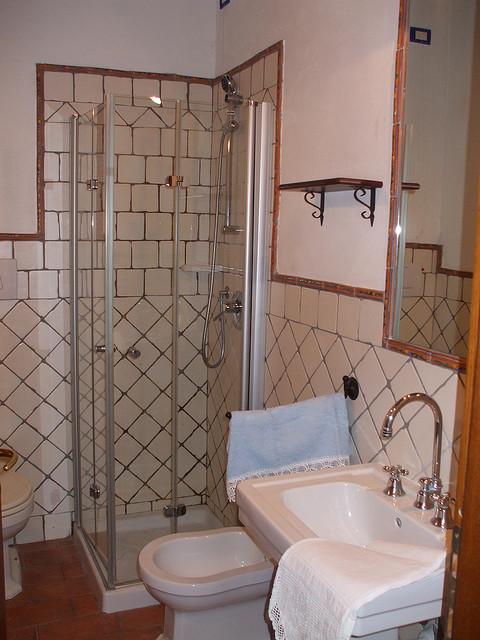How many showers are in the picture?
Write a very short answer. 1. What is the color of the sink?
Concise answer only. White. Do you see a person?
Answer briefly. No. 